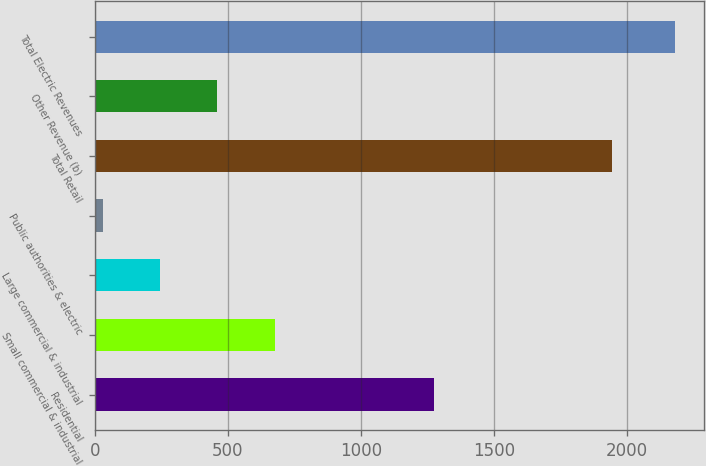<chart> <loc_0><loc_0><loc_500><loc_500><bar_chart><fcel>Residential<fcel>Small commercial & industrial<fcel>Large commercial & industrial<fcel>Public authorities & electric<fcel>Total Retail<fcel>Other Revenue (b)<fcel>Total Electric Revenues<nl><fcel>1274<fcel>675.9<fcel>245.3<fcel>30<fcel>1944<fcel>460.6<fcel>2183<nl></chart> 